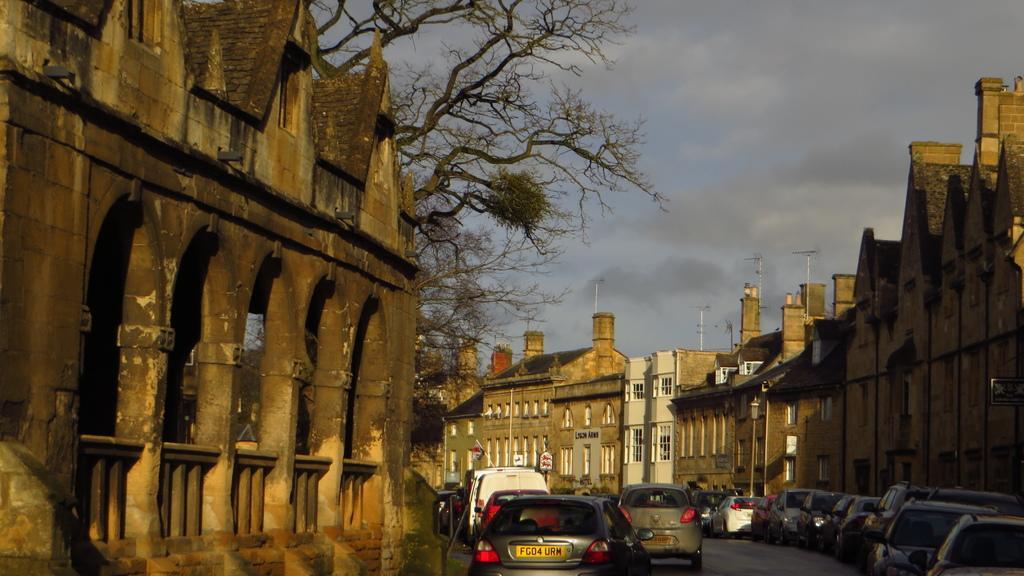Please provide a concise description of this image. This image consists of many buildings along with windows. In the front, we can see a tree. At the top, there are clouds in the sky. At the bottom, there are many cars parked on the road. 